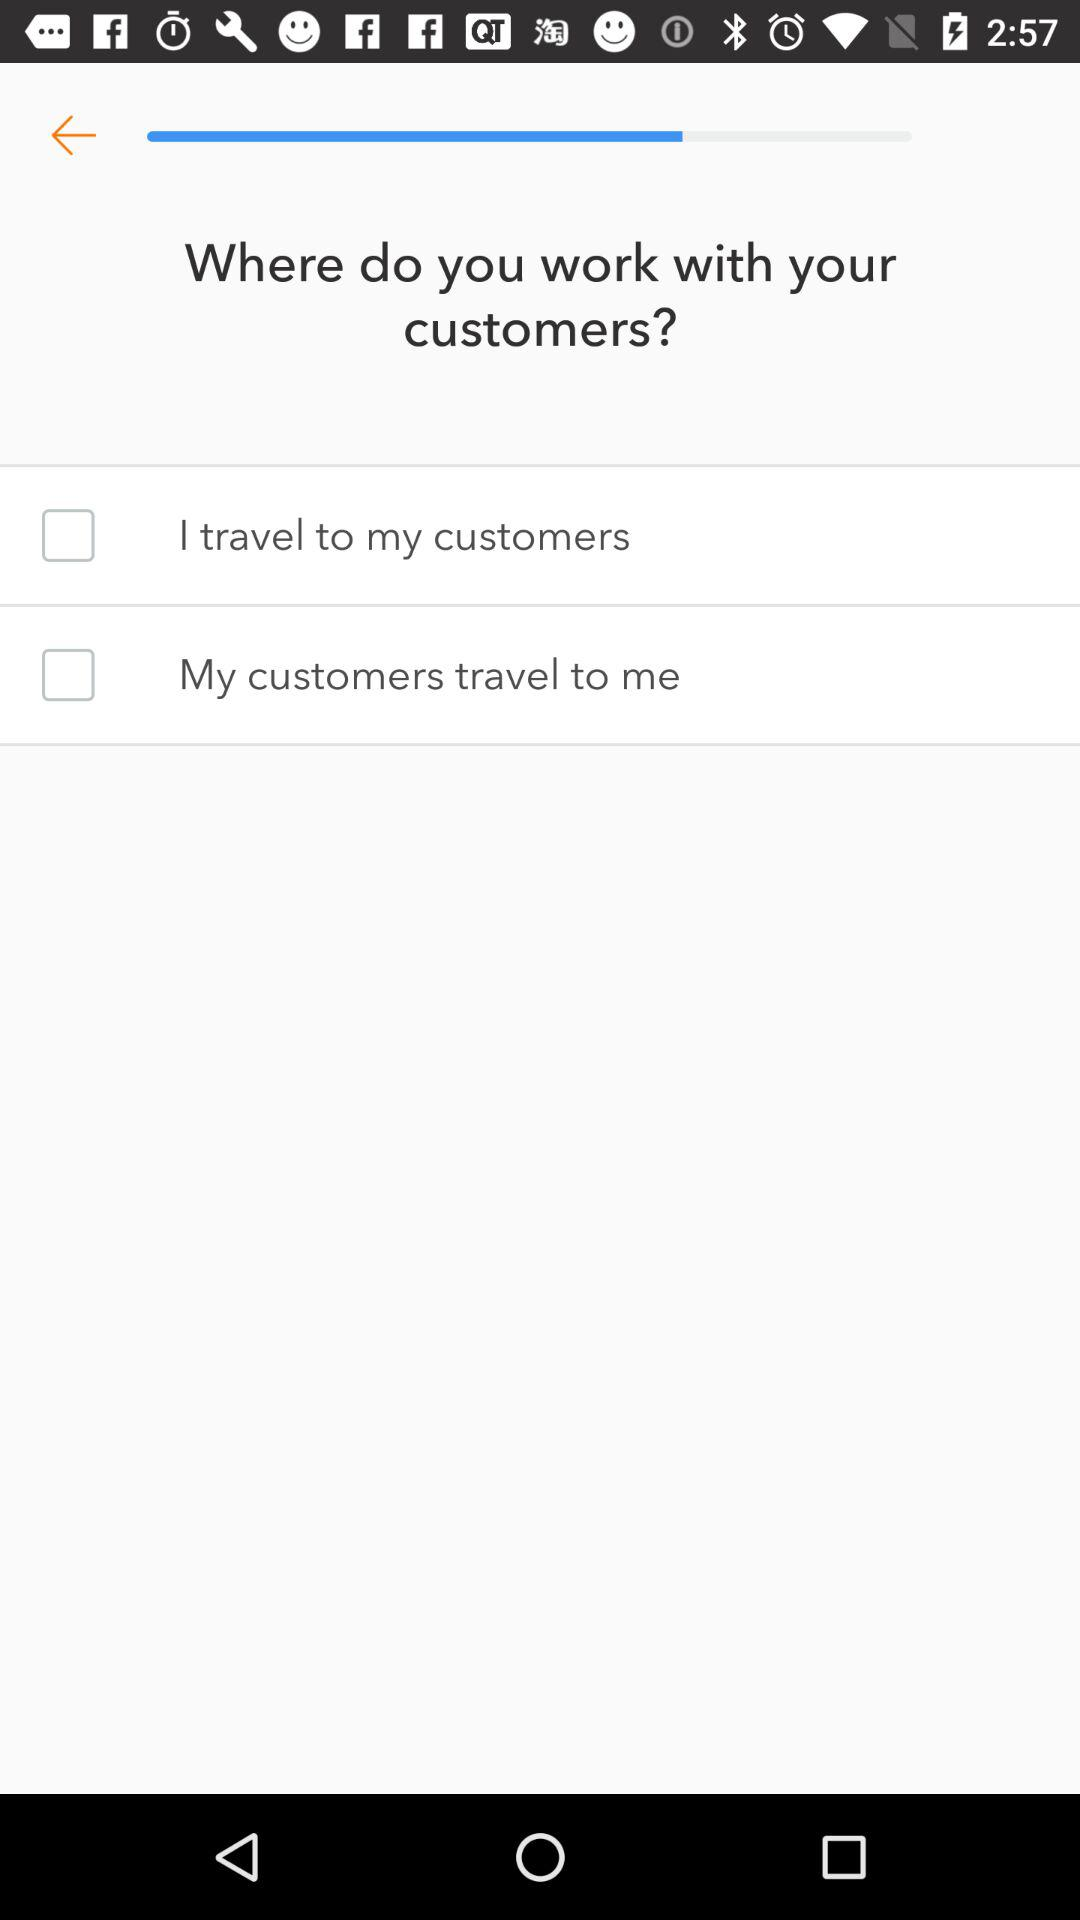How many options are there for where you work with your customers?
Answer the question using a single word or phrase. 2 